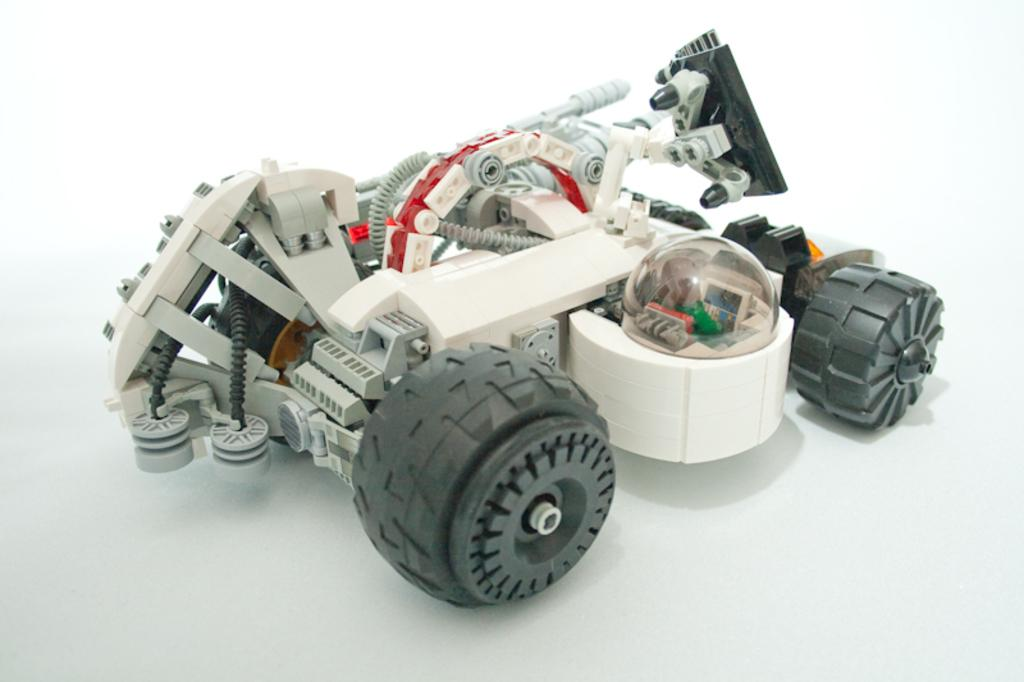What is the main object in the image? There is a toy car in the image. What feature of the toy car is mentioned in the facts? The toy car has wheels. What else can be seen in the image besides the toy car? There are wires and other objects fixed to the toy car. What is the color of the background in the image? The background of the image appears to be white in color. What scientific experiment is being conducted with the toy car in the image? There is no indication of a scientific experiment being conducted in the image; it simply shows a toy car with wheels and other objects attached to it. How many eyes can be seen on the toy car in the image? There are no eyes present on the toy car in the image, as it is an inanimate object. 